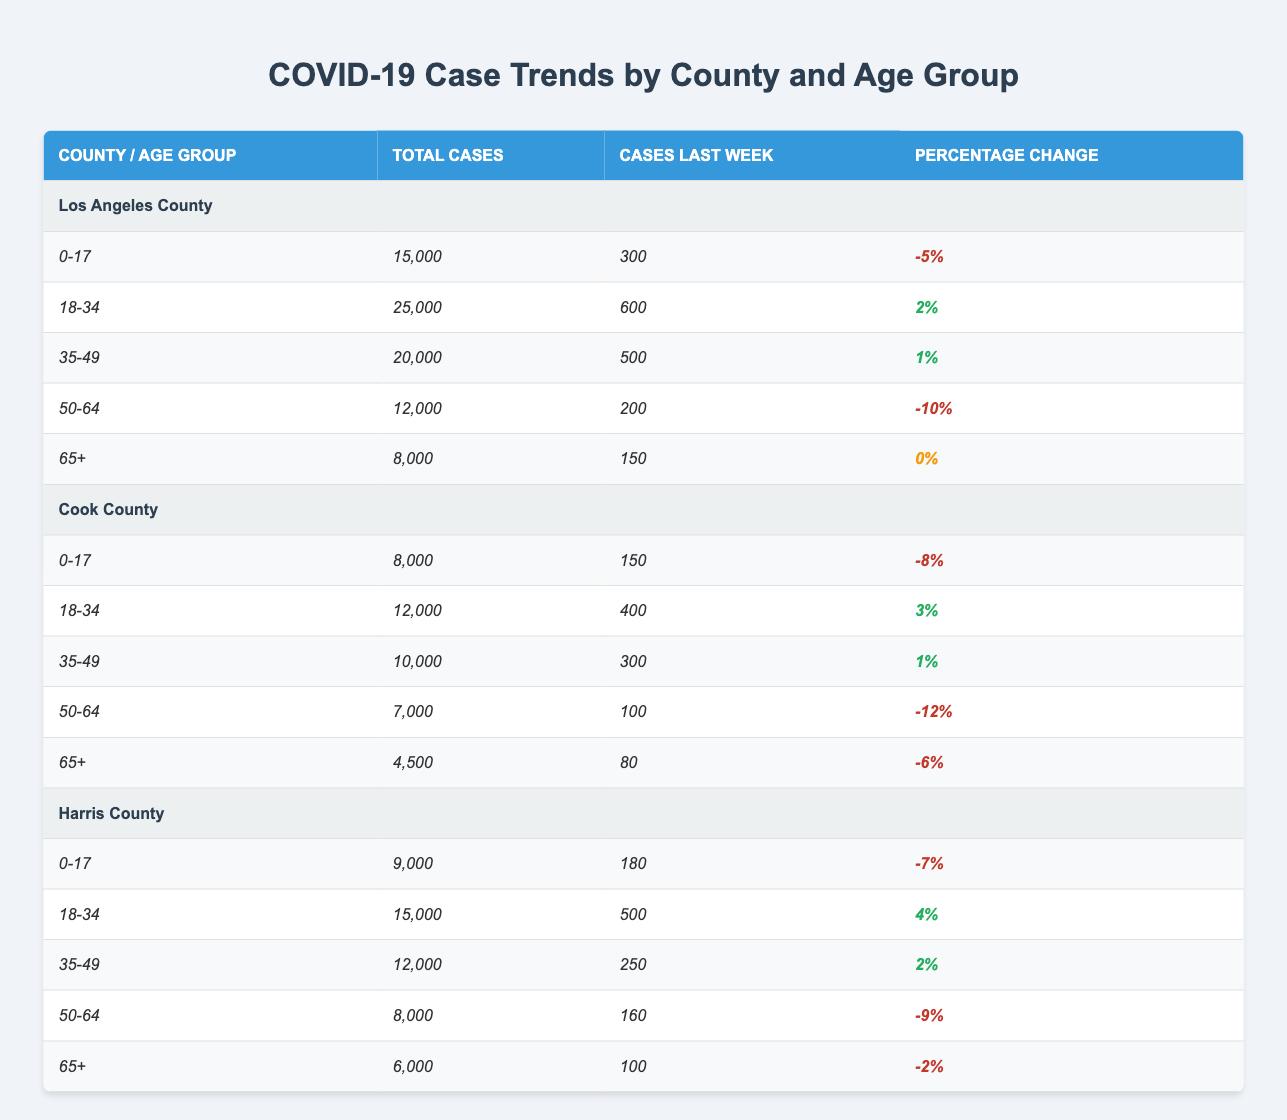What is the total number of COVID-19 cases in Los Angeles County for the age group 18-34? The table lists the total cases for each age group in Los Angeles County, and it specifies that there are 25,000 total cases in the 18-34 age group.
Answer: 25000 Which age group in Harris County has the highest total number of cases? The data shows the total cases for each age group in Harris County: 9,000 for 0-17, 15,000 for 18-34, 12,000 for 35-49, 8,000 for 50-64, and 6,000 for 65+. The highest number is 15,000 in the 18-34 age group.
Answer: 18-34 What is the percentage change of COVID-19 cases for the age group 50-64 in Cook County? The percentage change for the age group 50-64 in Cook County is listed in the table as -12%, indicating a decrease in cases compared to the previous period.
Answer: -12% Is it true that the percentage change for the 35-49 age group is positive in all counties? We compare the percentage change for the 35-49 age group across all counties: in Los Angeles County it is +1%, in Cook County it is +1%, and in Harris County it is +2%. All values are positive, so the statement is true.
Answer: Yes What is the average number of cases last week across all age groups in Los Angeles County? In Los Angeles County, the cases last week for each age group are: 300 (0-17), 600 (18-34), 500 (35-49), 200 (50-64), and 150 (65+). The total is 300 + 600 + 500 + 200 + 150 = 1850. Dividing by 5 (the number of age groups) gives an average of 370.
Answer: 370 Which age group had the least total cases in Cook County? By reviewing the total cases for Cook County, we find: 8,000 (0-17), 12,000 (18-34), 10,000 (35-49), 7,000 (50-64), and 4,500 (65+). The age group 65+ has the least total cases at 4,500.
Answer: 65+ What is the difference in total cases between the 0-17 age group in Los Angeles County and Harris County? The total cases for the 0-17 age group are 15,000 in Los Angeles County and 9,000 in Harris County. The difference is 15,000 - 9,000 = 6,000.
Answer: 6000 How many total cases are reported for all age groups in Cook County? To find the total cases for Cook County, we add the cases across all age groups: 8000 (0-17) + 12000 (18-34) + 10000 (35-49) + 7000 (50-64) + 4500 (65+) = 40,500.
Answer: 40500 What is the percentage change for the 0-17 age group in Harris County, and is it negative? The percentage change for the 0-17 age group in Harris County is reported as -7%. Since it is negative, the answer is negative.
Answer: Yes 